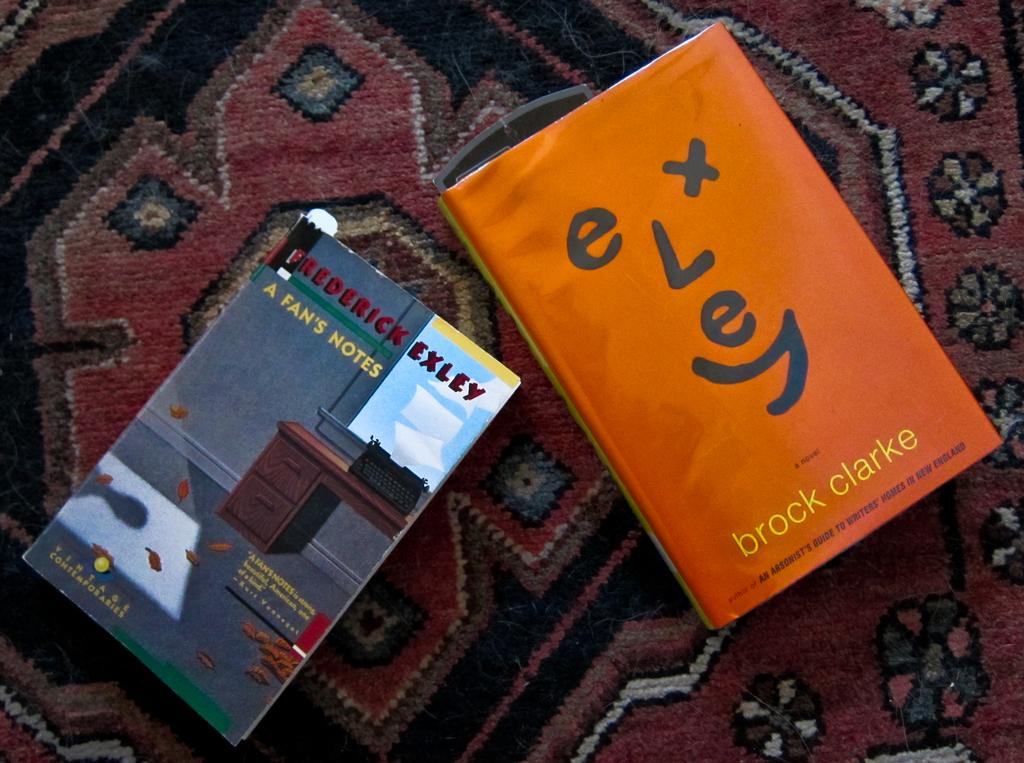How many books are visible in the image? There are two books in the image. Where are the books located? The books are on a bed sheet. Are there any fairies flying around the books in the image? No, there are no fairies present in the image. What type of base is supporting the books in the image? The books are on a bed sheet, so there is no specific base mentioned in the image. 